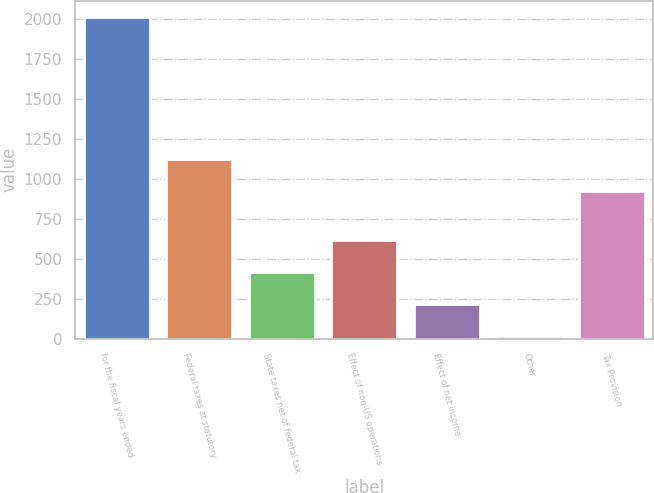<chart> <loc_0><loc_0><loc_500><loc_500><bar_chart><fcel>for the fiscal years ended<fcel>Federal taxes at statutory<fcel>State taxes net of federal tax<fcel>Effect of non-US operations<fcel>Effect of net income<fcel>Other<fcel>Tax Provision<nl><fcel>2015<fcel>1123.7<fcel>415<fcel>615<fcel>215<fcel>15<fcel>923.7<nl></chart> 